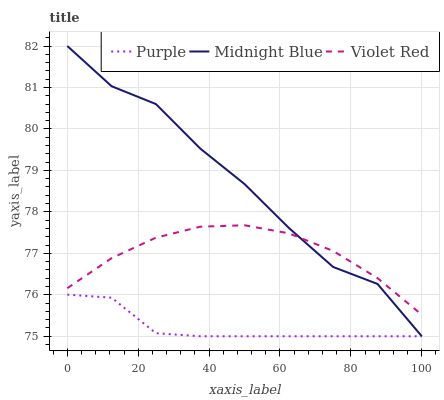Does Purple have the minimum area under the curve?
Answer yes or no. Yes. Does Midnight Blue have the maximum area under the curve?
Answer yes or no. Yes. Does Violet Red have the minimum area under the curve?
Answer yes or no. No. Does Violet Red have the maximum area under the curve?
Answer yes or no. No. Is Violet Red the smoothest?
Answer yes or no. Yes. Is Midnight Blue the roughest?
Answer yes or no. Yes. Is Midnight Blue the smoothest?
Answer yes or no. No. Is Violet Red the roughest?
Answer yes or no. No. Does Violet Red have the lowest value?
Answer yes or no. No. Does Midnight Blue have the highest value?
Answer yes or no. Yes. Does Violet Red have the highest value?
Answer yes or no. No. Is Purple less than Violet Red?
Answer yes or no. Yes. Is Violet Red greater than Purple?
Answer yes or no. Yes. Does Purple intersect Violet Red?
Answer yes or no. No. 